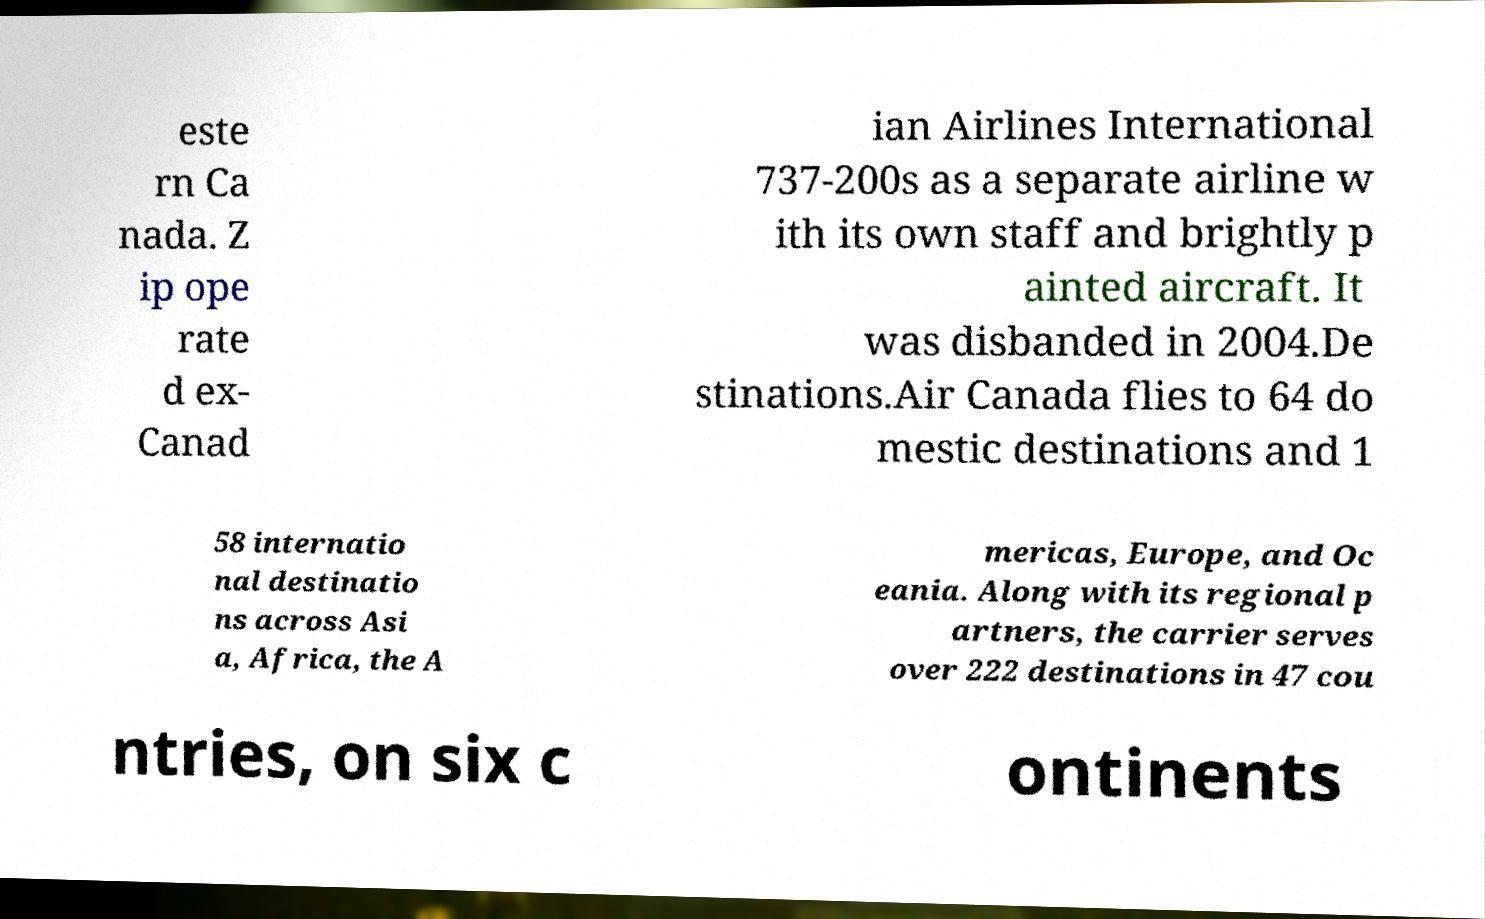Could you extract and type out the text from this image? este rn Ca nada. Z ip ope rate d ex- Canad ian Airlines International 737-200s as a separate airline w ith its own staff and brightly p ainted aircraft. It was disbanded in 2004.De stinations.Air Canada flies to 64 do mestic destinations and 1 58 internatio nal destinatio ns across Asi a, Africa, the A mericas, Europe, and Oc eania. Along with its regional p artners, the carrier serves over 222 destinations in 47 cou ntries, on six c ontinents 